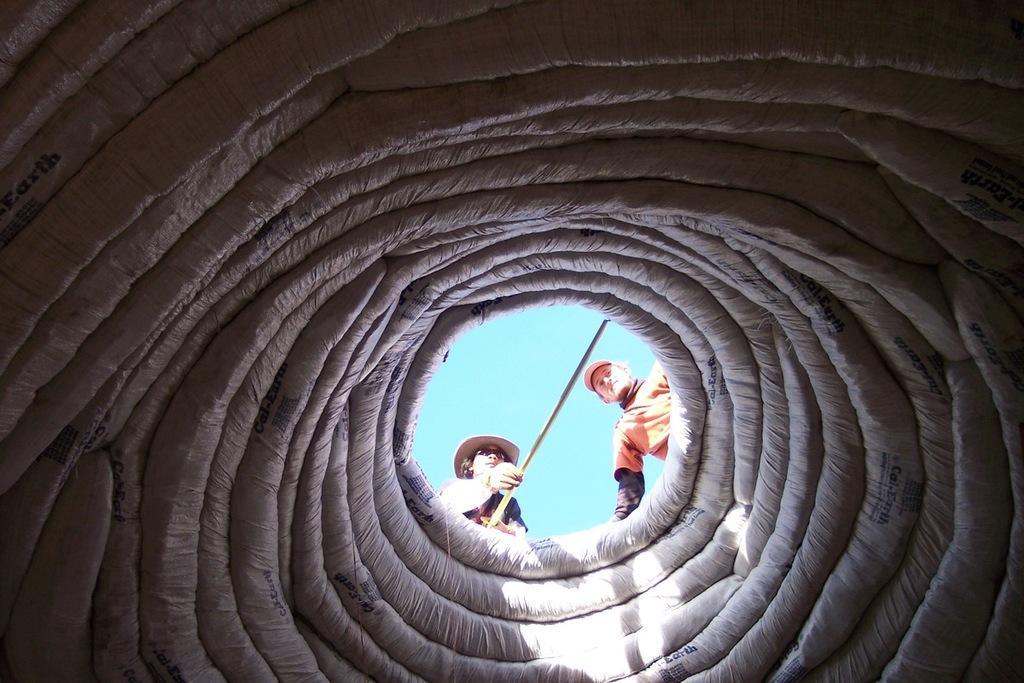Could you give a brief overview of what you see in this image? In this image, I can see a circular shaped object, two persons, stick and the sky. This image is taken, maybe during a day. 